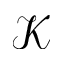<formula> <loc_0><loc_0><loc_500><loc_500>\mathcal { K }</formula> 